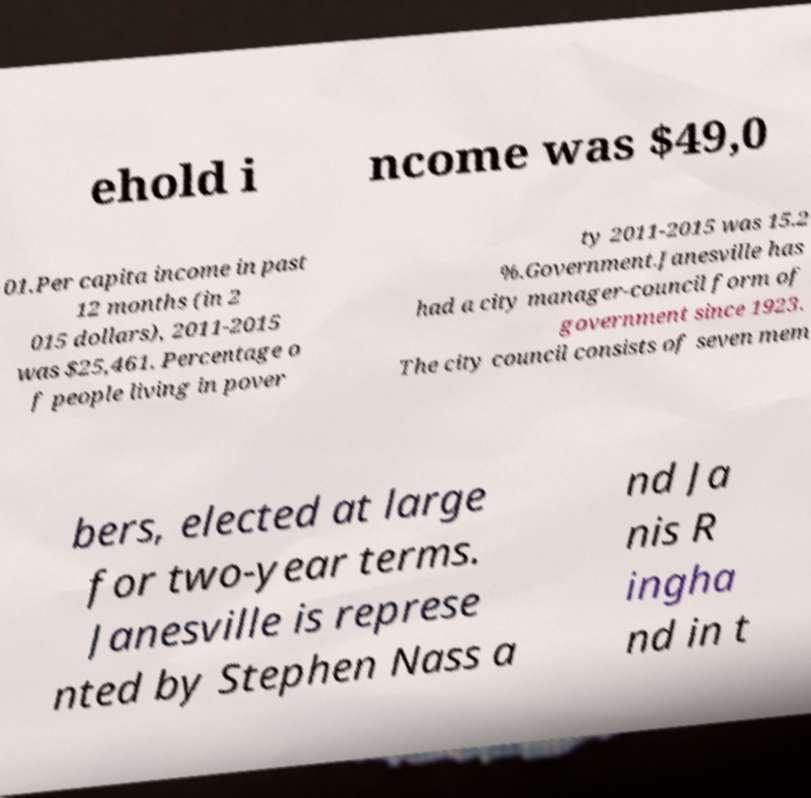Please read and relay the text visible in this image. What does it say? ehold i ncome was $49,0 01.Per capita income in past 12 months (in 2 015 dollars), 2011-2015 was $25,461. Percentage o f people living in pover ty 2011-2015 was 15.2 %.Government.Janesville has had a city manager-council form of government since 1923. The city council consists of seven mem bers, elected at large for two-year terms. Janesville is represe nted by Stephen Nass a nd Ja nis R ingha nd in t 